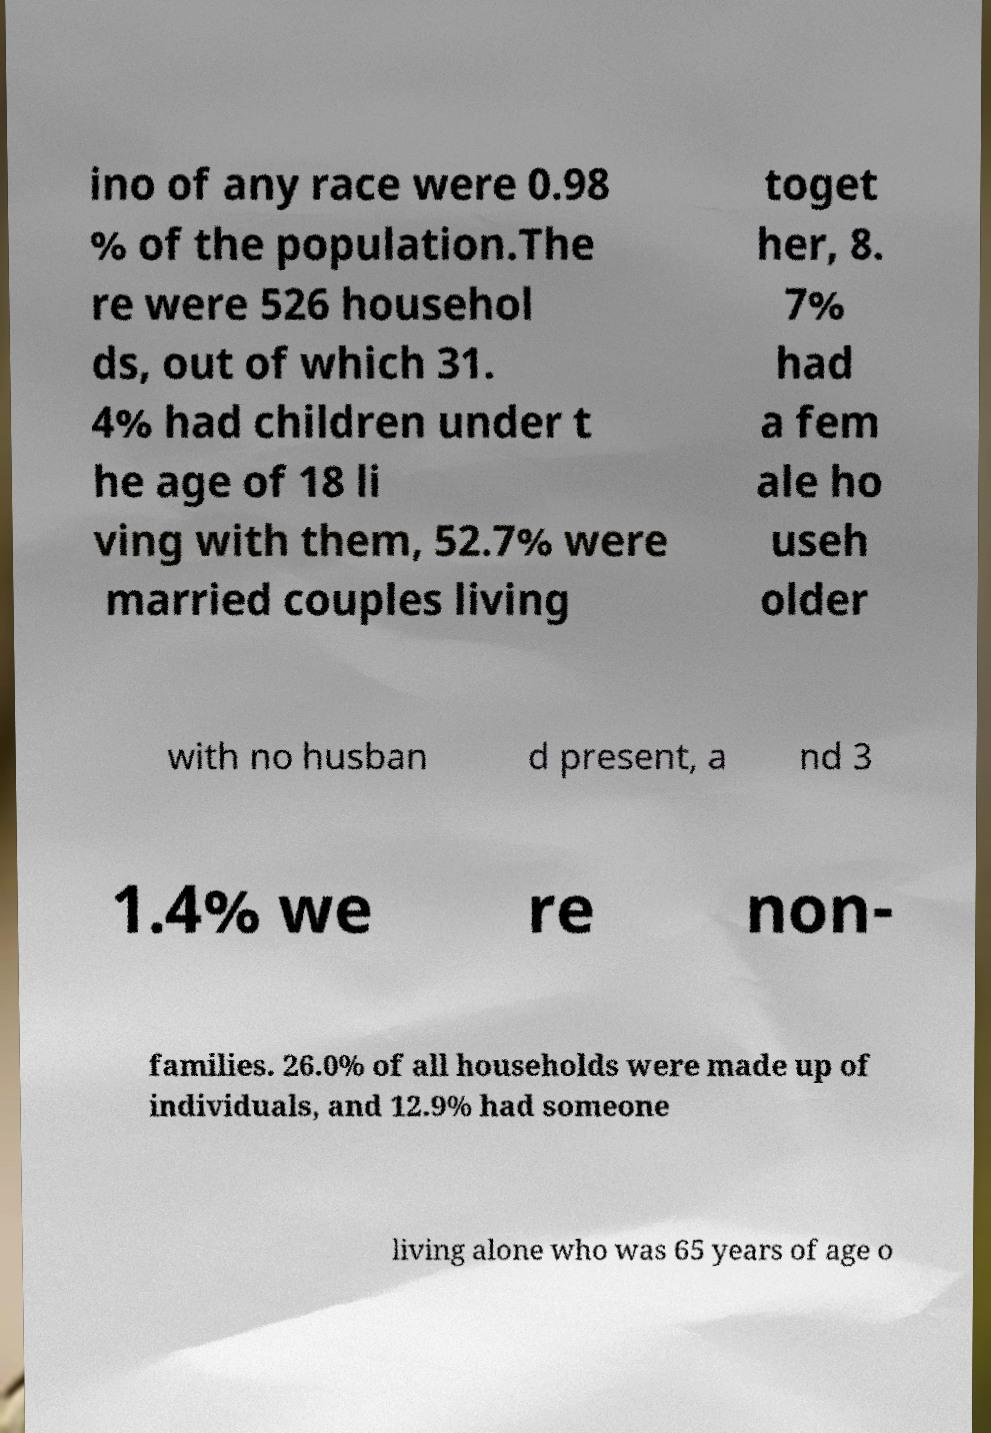Could you extract and type out the text from this image? ino of any race were 0.98 % of the population.The re were 526 househol ds, out of which 31. 4% had children under t he age of 18 li ving with them, 52.7% were married couples living toget her, 8. 7% had a fem ale ho useh older with no husban d present, a nd 3 1.4% we re non- families. 26.0% of all households were made up of individuals, and 12.9% had someone living alone who was 65 years of age o 